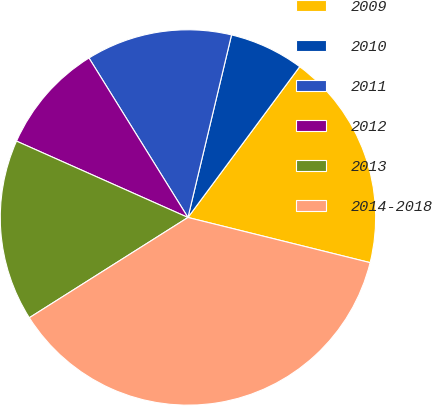<chart> <loc_0><loc_0><loc_500><loc_500><pie_chart><fcel>2009<fcel>2010<fcel>2011<fcel>2012<fcel>2013<fcel>2014-2018<nl><fcel>18.72%<fcel>6.42%<fcel>12.57%<fcel>9.49%<fcel>15.64%<fcel>37.16%<nl></chart> 